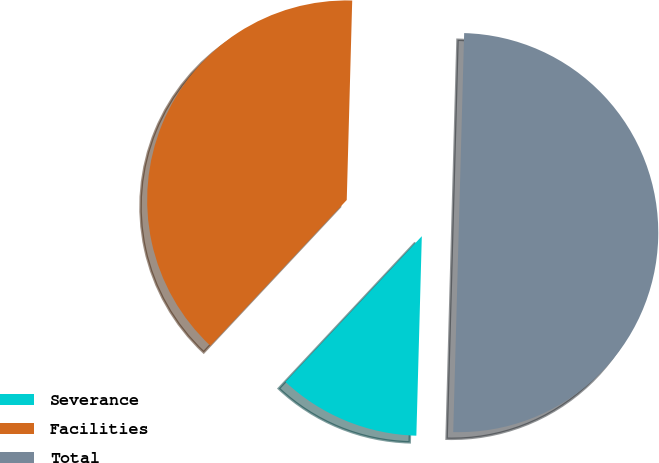Convert chart. <chart><loc_0><loc_0><loc_500><loc_500><pie_chart><fcel>Severance<fcel>Facilities<fcel>Total<nl><fcel>11.54%<fcel>38.46%<fcel>50.0%<nl></chart> 